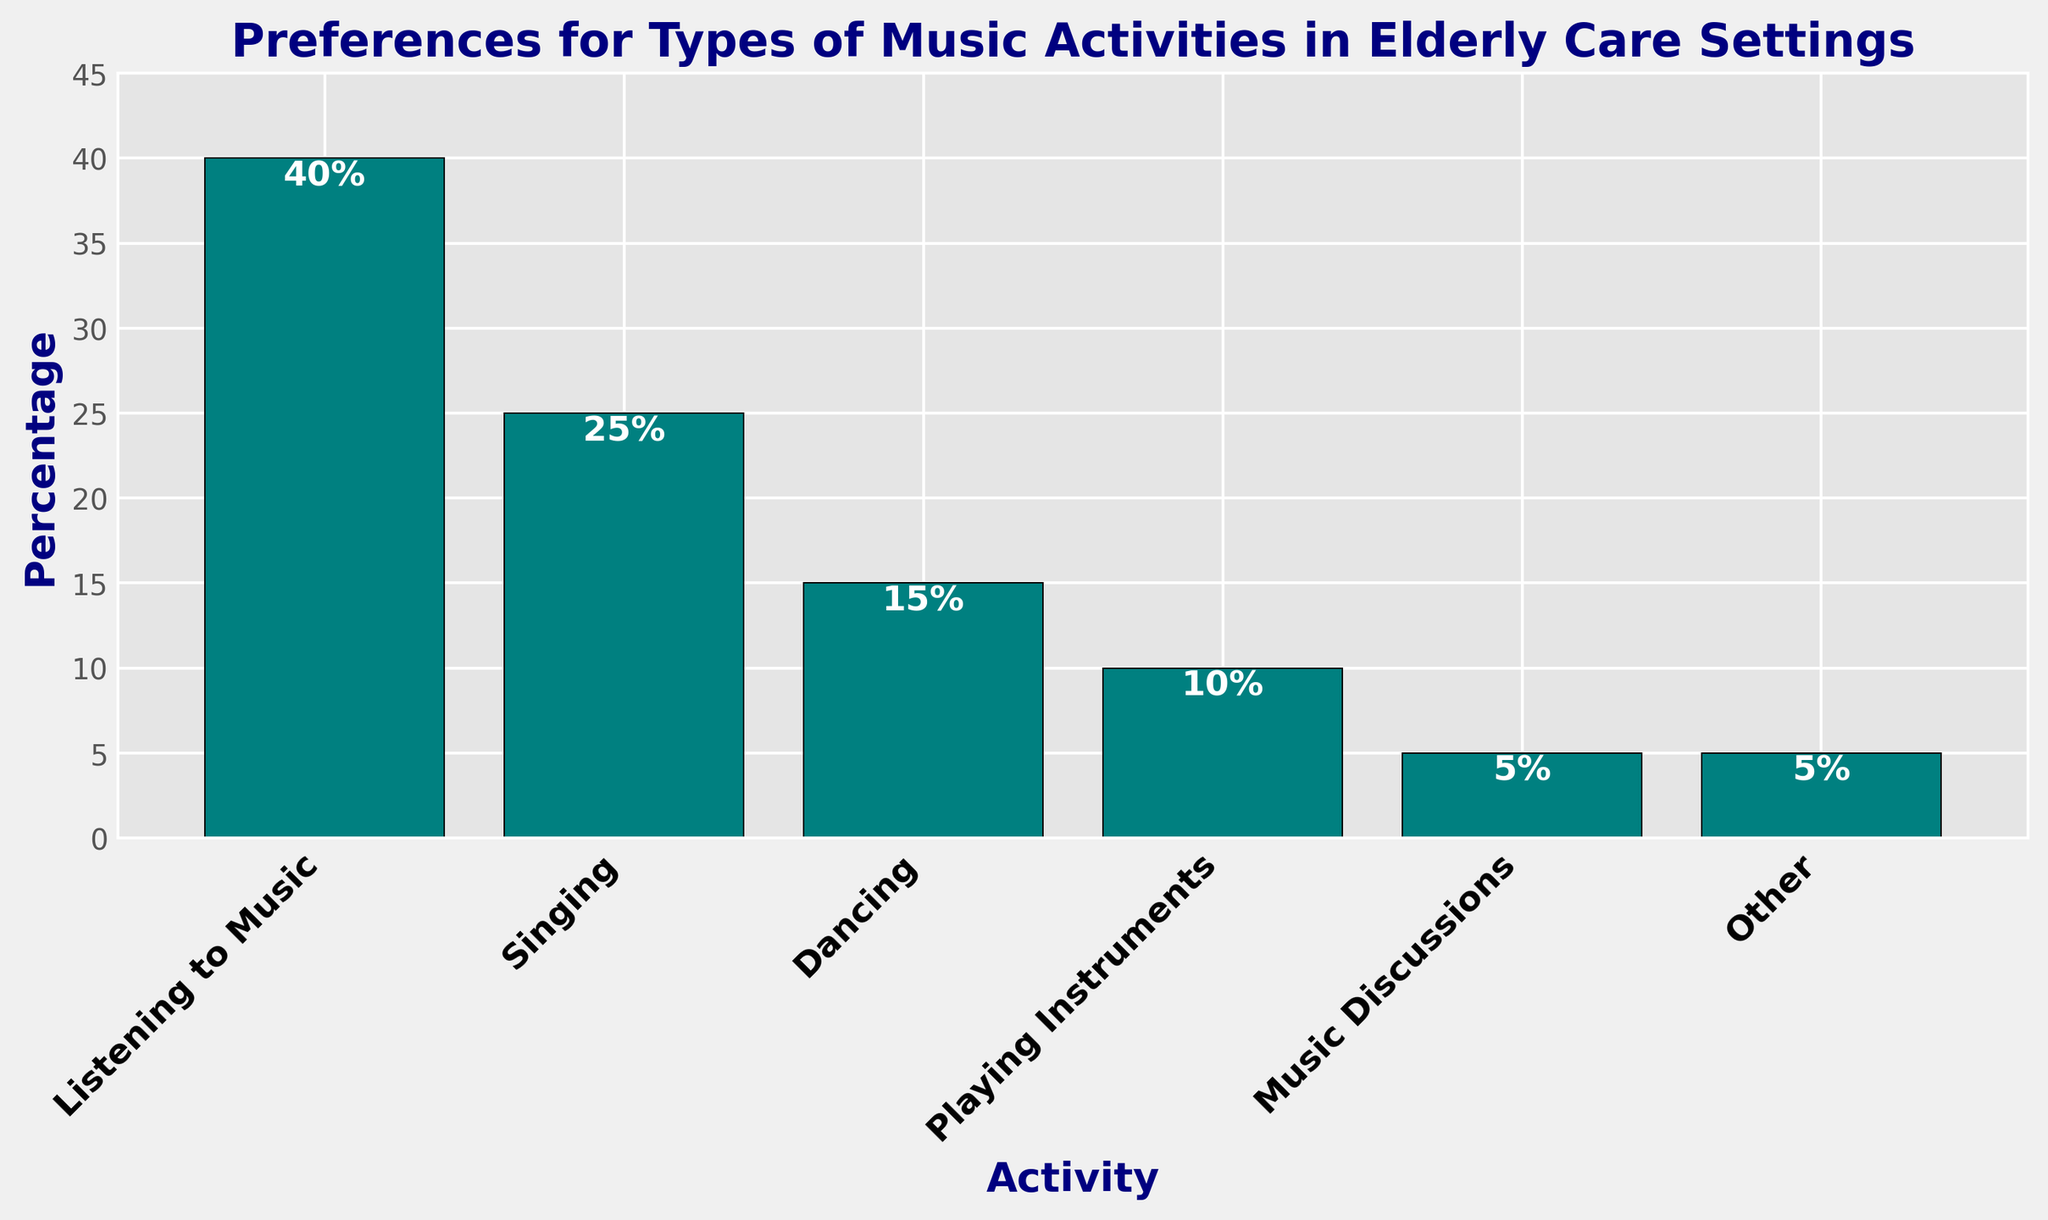Which activity has the highest percentage of preference? The bar for "Listening to Music" is the tallest, and the text annotation on it indicates 40%, showing that it has the highest preference among the activities listed.
Answer: Listening to Music What is the difference in preference percentage between "Singing" and "Dancing"? The bar for "Singing" indicates 25%, and the bar for "Dancing" shows 15%. The difference is calculated as 25% - 15% = 10%.
Answer: 10% Which activities have the same percentage of preference? The bars for "Music Discussions" and "Other" both reach up to 5%, indicating they share the same percentage of preference.
Answer: Music Discussions and Other What is the combined preference percentage for activities other than "Listening to Music"? Adding percentage values for all activities except "Listening to Music": 25% (Singing) + 15% (Dancing) + 10% (Playing Instruments) + 5% (Music Discussions) + 5% (Other) = 60%.
Answer: 60% Which activity is preferred more: "Playing Instruments" or "Dancing"? The bar for "Dancing" reaches 15%, while the bar for "Playing Instruments" reaches 10%, indicating "Dancing" is preferred more.
Answer: Dancing Which activity has the lowest preference percentage, and what is that percentage? Both "Music Discussions" and "Other" have the smallest bars, and their text annotations show they each have a preference percentage of 5%.
Answer: Music Discussions and Other, 5% What is the average preference percentage of all the activities? Sum of percentages: 40% + 25% + 15% + 10% + 5% + 5% = 100%. Number of activities: 6. The average is calculated as 100% / 6 ≈ 16.67%.
Answer: 16.67% What percentage of people preferred "Singing" and "Playing Instruments" combined? Adding the percentages for "Singing" and "Playing Instruments": 25% + 10% = 35%.
Answer: 35% Is the preference for "Listening to Music" greater than the combined preference for "Singing" and "Dancing"? The preference for "Listening to Music" is 40%. The combined preference for "Singing" and "Dancing" is 25% + 15% = 40%. Since 40% is equal to 40%, the preference for "Listening to Music" is equal to the combined preference for "Singing" and "Dancing".
Answer: No 